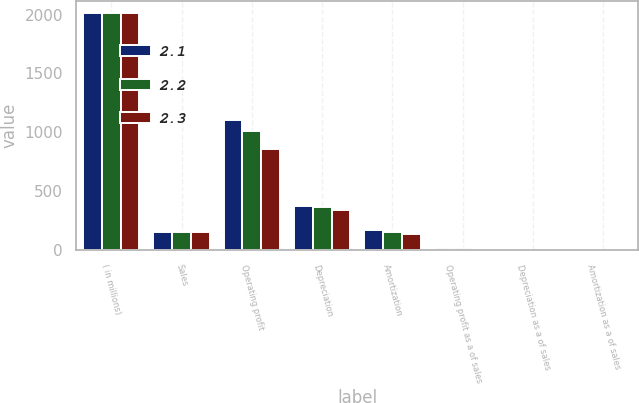Convert chart. <chart><loc_0><loc_0><loc_500><loc_500><stacked_bar_chart><ecel><fcel>( in millions)<fcel>Sales<fcel>Operating profit<fcel>Depreciation<fcel>Amortization<fcel>Operating profit as a of sales<fcel>Depreciation as a of sales<fcel>Amortization as a of sales<nl><fcel>2.1<fcel>2014<fcel>154<fcel>1105.9<fcel>371.9<fcel>167.1<fcel>15.4<fcel>5.2<fcel>2.3<nl><fcel>2.2<fcel>2013<fcel>154<fcel>1009.8<fcel>363.3<fcel>154<fcel>14.7<fcel>5.3<fcel>2.2<nl><fcel>2.3<fcel>2012<fcel>154<fcel>861.1<fcel>338.8<fcel>139.4<fcel>13.3<fcel>5.2<fcel>2.1<nl></chart> 